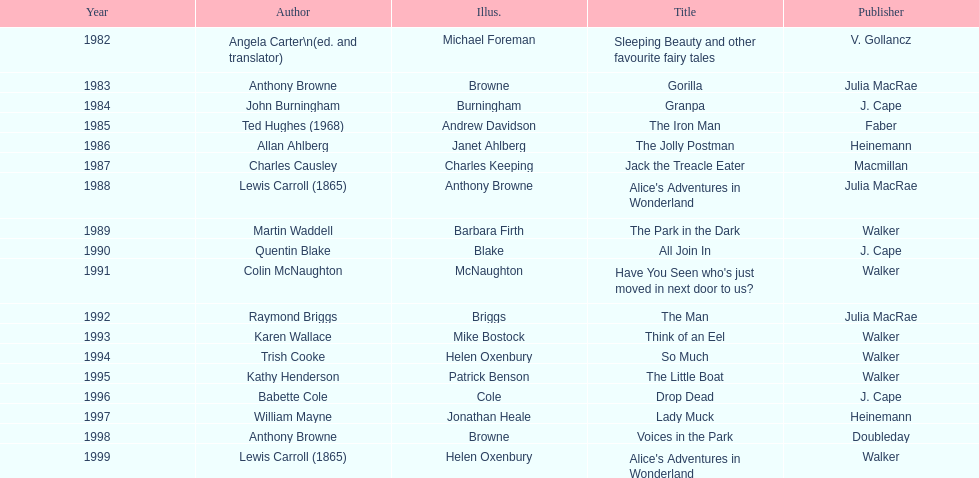Which title was after the year 1991 but before the year 1993? The Man. 